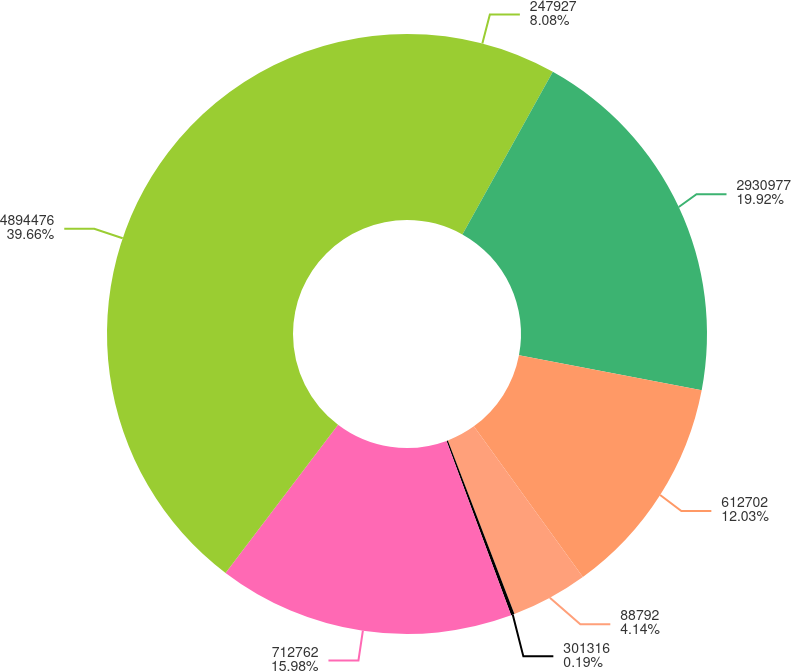Convert chart. <chart><loc_0><loc_0><loc_500><loc_500><pie_chart><fcel>247927<fcel>2930977<fcel>612702<fcel>88792<fcel>301316<fcel>712762<fcel>4894476<nl><fcel>8.08%<fcel>19.92%<fcel>12.03%<fcel>4.14%<fcel>0.19%<fcel>15.98%<fcel>39.66%<nl></chart> 